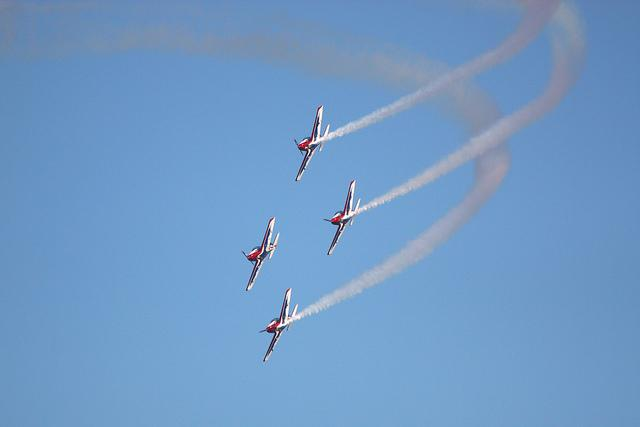The planes are executing a what? formation 